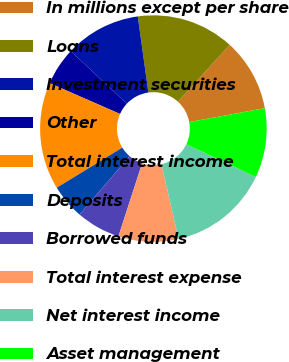Convert chart to OTSL. <chart><loc_0><loc_0><loc_500><loc_500><pie_chart><fcel>In millions except per share<fcel>Loans<fcel>Investment securities<fcel>Other<fcel>Total interest income<fcel>Deposits<fcel>Borrowed funds<fcel>Total interest expense<fcel>Net interest income<fcel>Asset management<nl><fcel>10.36%<fcel>13.96%<fcel>10.81%<fcel>5.41%<fcel>15.31%<fcel>4.96%<fcel>6.31%<fcel>8.56%<fcel>14.41%<fcel>9.91%<nl></chart> 